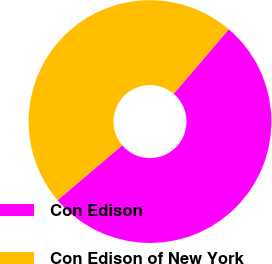<chart> <loc_0><loc_0><loc_500><loc_500><pie_chart><fcel>Con Edison<fcel>Con Edison of New York<nl><fcel>52.54%<fcel>47.46%<nl></chart> 